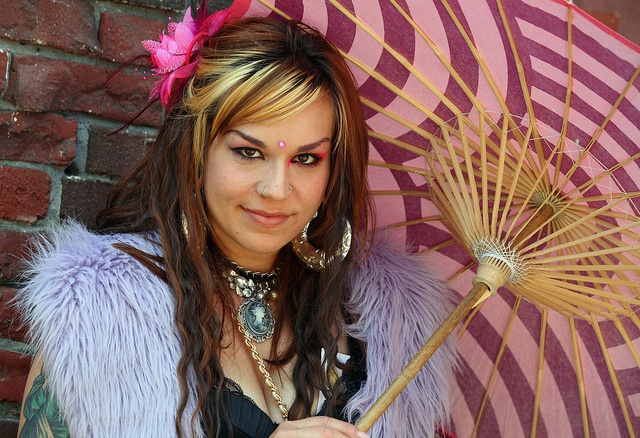Describe the objects in this image and their specific colors. I can see people in brown, black, maroon, and darkgray tones and umbrella in brown, lightpink, and tan tones in this image. 